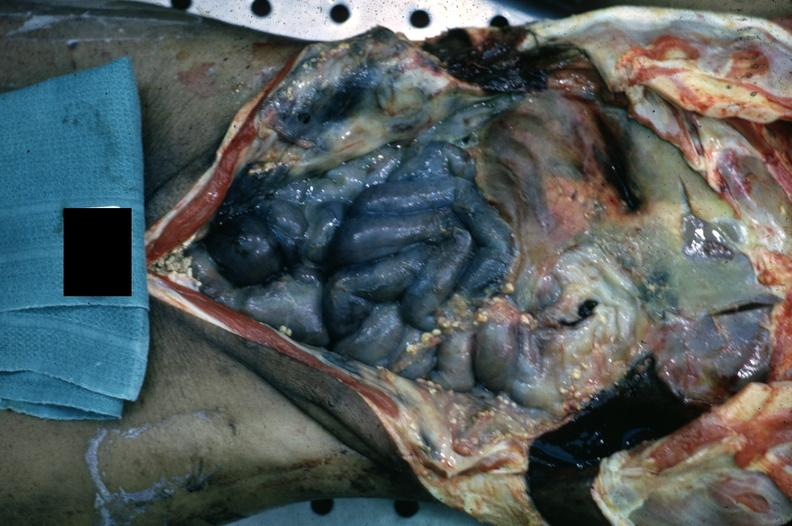s peritoneum present?
Answer the question using a single word or phrase. Yes 